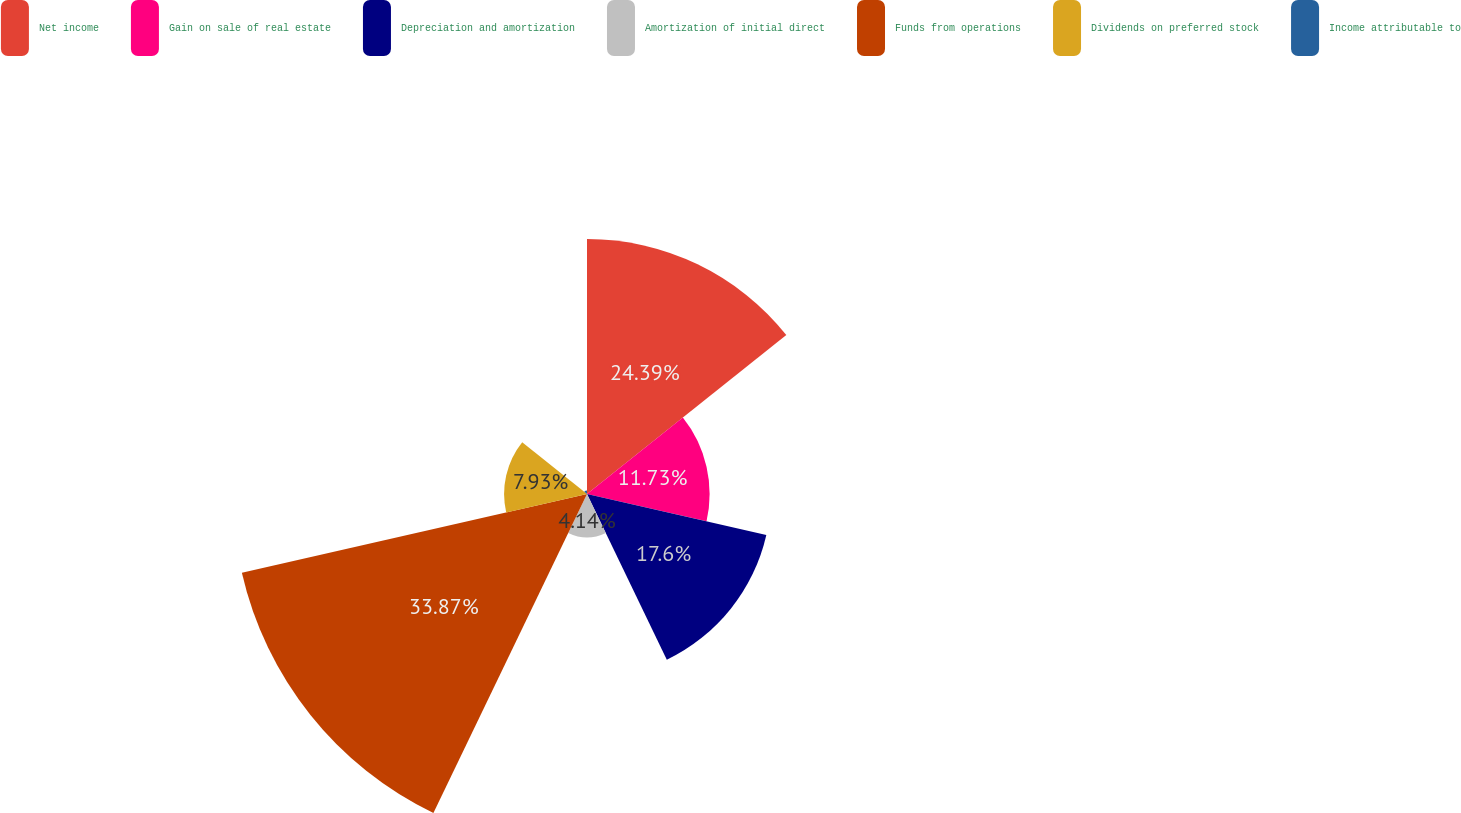Convert chart to OTSL. <chart><loc_0><loc_0><loc_500><loc_500><pie_chart><fcel>Net income<fcel>Gain on sale of real estate<fcel>Depreciation and amortization<fcel>Amortization of initial direct<fcel>Funds from operations<fcel>Dividends on preferred stock<fcel>Income attributable to<nl><fcel>24.39%<fcel>11.73%<fcel>17.6%<fcel>4.14%<fcel>33.87%<fcel>7.93%<fcel>0.34%<nl></chart> 